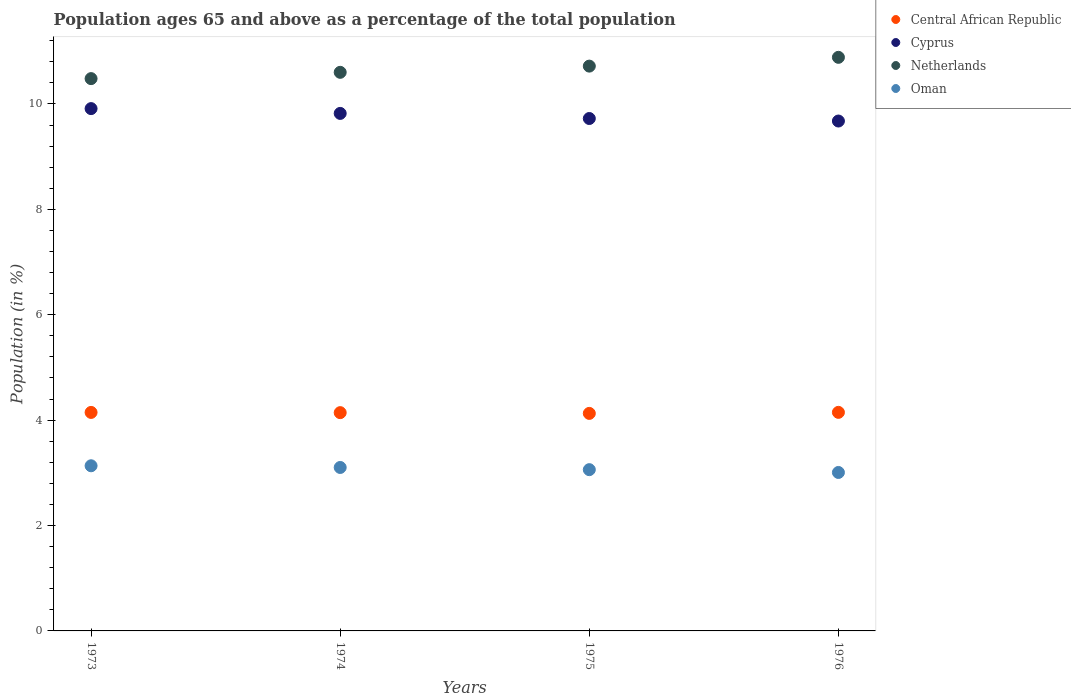Is the number of dotlines equal to the number of legend labels?
Offer a terse response. Yes. What is the percentage of the population ages 65 and above in Central African Republic in 1974?
Make the answer very short. 4.14. Across all years, what is the maximum percentage of the population ages 65 and above in Cyprus?
Give a very brief answer. 9.91. Across all years, what is the minimum percentage of the population ages 65 and above in Oman?
Offer a very short reply. 3.01. In which year was the percentage of the population ages 65 and above in Oman maximum?
Keep it short and to the point. 1973. In which year was the percentage of the population ages 65 and above in Cyprus minimum?
Ensure brevity in your answer.  1976. What is the total percentage of the population ages 65 and above in Netherlands in the graph?
Your answer should be compact. 42.68. What is the difference between the percentage of the population ages 65 and above in Oman in 1974 and that in 1976?
Offer a very short reply. 0.09. What is the difference between the percentage of the population ages 65 and above in Cyprus in 1975 and the percentage of the population ages 65 and above in Central African Republic in 1974?
Make the answer very short. 5.58. What is the average percentage of the population ages 65 and above in Central African Republic per year?
Your response must be concise. 4.14. In the year 1974, what is the difference between the percentage of the population ages 65 and above in Cyprus and percentage of the population ages 65 and above in Oman?
Make the answer very short. 6.72. In how many years, is the percentage of the population ages 65 and above in Netherlands greater than 8?
Ensure brevity in your answer.  4. What is the ratio of the percentage of the population ages 65 and above in Central African Republic in 1973 to that in 1975?
Provide a succinct answer. 1. Is the percentage of the population ages 65 and above in Cyprus in 1973 less than that in 1975?
Give a very brief answer. No. Is the difference between the percentage of the population ages 65 and above in Cyprus in 1973 and 1976 greater than the difference between the percentage of the population ages 65 and above in Oman in 1973 and 1976?
Ensure brevity in your answer.  Yes. What is the difference between the highest and the second highest percentage of the population ages 65 and above in Netherlands?
Provide a short and direct response. 0.17. What is the difference between the highest and the lowest percentage of the population ages 65 and above in Oman?
Provide a short and direct response. 0.13. In how many years, is the percentage of the population ages 65 and above in Netherlands greater than the average percentage of the population ages 65 and above in Netherlands taken over all years?
Your response must be concise. 2. Is it the case that in every year, the sum of the percentage of the population ages 65 and above in Central African Republic and percentage of the population ages 65 and above in Netherlands  is greater than the sum of percentage of the population ages 65 and above in Oman and percentage of the population ages 65 and above in Cyprus?
Provide a succinct answer. Yes. Is it the case that in every year, the sum of the percentage of the population ages 65 and above in Netherlands and percentage of the population ages 65 and above in Cyprus  is greater than the percentage of the population ages 65 and above in Central African Republic?
Ensure brevity in your answer.  Yes. Does the percentage of the population ages 65 and above in Cyprus monotonically increase over the years?
Keep it short and to the point. No. Is the percentage of the population ages 65 and above in Oman strictly greater than the percentage of the population ages 65 and above in Netherlands over the years?
Give a very brief answer. No. How many dotlines are there?
Offer a terse response. 4. Where does the legend appear in the graph?
Give a very brief answer. Top right. How are the legend labels stacked?
Your answer should be very brief. Vertical. What is the title of the graph?
Make the answer very short. Population ages 65 and above as a percentage of the total population. Does "Europe(all income levels)" appear as one of the legend labels in the graph?
Keep it short and to the point. No. What is the label or title of the X-axis?
Make the answer very short. Years. What is the Population (in %) in Central African Republic in 1973?
Offer a very short reply. 4.15. What is the Population (in %) of Cyprus in 1973?
Keep it short and to the point. 9.91. What is the Population (in %) in Netherlands in 1973?
Give a very brief answer. 10.48. What is the Population (in %) in Oman in 1973?
Your answer should be very brief. 3.13. What is the Population (in %) of Central African Republic in 1974?
Offer a terse response. 4.14. What is the Population (in %) of Cyprus in 1974?
Offer a terse response. 9.82. What is the Population (in %) of Netherlands in 1974?
Offer a very short reply. 10.6. What is the Population (in %) in Oman in 1974?
Ensure brevity in your answer.  3.1. What is the Population (in %) in Central African Republic in 1975?
Your response must be concise. 4.13. What is the Population (in %) in Cyprus in 1975?
Keep it short and to the point. 9.72. What is the Population (in %) of Netherlands in 1975?
Give a very brief answer. 10.72. What is the Population (in %) in Oman in 1975?
Offer a terse response. 3.06. What is the Population (in %) in Central African Republic in 1976?
Give a very brief answer. 4.15. What is the Population (in %) of Cyprus in 1976?
Provide a succinct answer. 9.68. What is the Population (in %) of Netherlands in 1976?
Provide a succinct answer. 10.88. What is the Population (in %) in Oman in 1976?
Make the answer very short. 3.01. Across all years, what is the maximum Population (in %) in Central African Republic?
Give a very brief answer. 4.15. Across all years, what is the maximum Population (in %) of Cyprus?
Your response must be concise. 9.91. Across all years, what is the maximum Population (in %) of Netherlands?
Provide a short and direct response. 10.88. Across all years, what is the maximum Population (in %) in Oman?
Keep it short and to the point. 3.13. Across all years, what is the minimum Population (in %) in Central African Republic?
Your response must be concise. 4.13. Across all years, what is the minimum Population (in %) in Cyprus?
Your answer should be very brief. 9.68. Across all years, what is the minimum Population (in %) in Netherlands?
Make the answer very short. 10.48. Across all years, what is the minimum Population (in %) of Oman?
Provide a short and direct response. 3.01. What is the total Population (in %) in Central African Republic in the graph?
Offer a very short reply. 16.56. What is the total Population (in %) in Cyprus in the graph?
Give a very brief answer. 39.13. What is the total Population (in %) of Netherlands in the graph?
Ensure brevity in your answer.  42.68. What is the total Population (in %) in Oman in the graph?
Ensure brevity in your answer.  12.3. What is the difference between the Population (in %) in Central African Republic in 1973 and that in 1974?
Give a very brief answer. 0. What is the difference between the Population (in %) of Cyprus in 1973 and that in 1974?
Offer a very short reply. 0.09. What is the difference between the Population (in %) in Netherlands in 1973 and that in 1974?
Keep it short and to the point. -0.12. What is the difference between the Population (in %) of Oman in 1973 and that in 1974?
Your response must be concise. 0.03. What is the difference between the Population (in %) of Central African Republic in 1973 and that in 1975?
Give a very brief answer. 0.02. What is the difference between the Population (in %) in Cyprus in 1973 and that in 1975?
Provide a short and direct response. 0.19. What is the difference between the Population (in %) of Netherlands in 1973 and that in 1975?
Offer a terse response. -0.24. What is the difference between the Population (in %) of Oman in 1973 and that in 1975?
Offer a very short reply. 0.07. What is the difference between the Population (in %) of Central African Republic in 1973 and that in 1976?
Offer a very short reply. -0. What is the difference between the Population (in %) of Cyprus in 1973 and that in 1976?
Provide a short and direct response. 0.24. What is the difference between the Population (in %) in Netherlands in 1973 and that in 1976?
Give a very brief answer. -0.4. What is the difference between the Population (in %) of Oman in 1973 and that in 1976?
Offer a very short reply. 0.13. What is the difference between the Population (in %) in Central African Republic in 1974 and that in 1975?
Your answer should be compact. 0.01. What is the difference between the Population (in %) in Cyprus in 1974 and that in 1975?
Ensure brevity in your answer.  0.1. What is the difference between the Population (in %) of Netherlands in 1974 and that in 1975?
Give a very brief answer. -0.12. What is the difference between the Population (in %) in Oman in 1974 and that in 1975?
Provide a short and direct response. 0.04. What is the difference between the Population (in %) in Central African Republic in 1974 and that in 1976?
Make the answer very short. -0.01. What is the difference between the Population (in %) of Cyprus in 1974 and that in 1976?
Offer a very short reply. 0.14. What is the difference between the Population (in %) of Netherlands in 1974 and that in 1976?
Your answer should be very brief. -0.28. What is the difference between the Population (in %) in Oman in 1974 and that in 1976?
Your answer should be compact. 0.09. What is the difference between the Population (in %) in Central African Republic in 1975 and that in 1976?
Ensure brevity in your answer.  -0.02. What is the difference between the Population (in %) of Cyprus in 1975 and that in 1976?
Keep it short and to the point. 0.05. What is the difference between the Population (in %) of Netherlands in 1975 and that in 1976?
Make the answer very short. -0.17. What is the difference between the Population (in %) of Oman in 1975 and that in 1976?
Your answer should be compact. 0.05. What is the difference between the Population (in %) in Central African Republic in 1973 and the Population (in %) in Cyprus in 1974?
Make the answer very short. -5.67. What is the difference between the Population (in %) in Central African Republic in 1973 and the Population (in %) in Netherlands in 1974?
Provide a short and direct response. -6.45. What is the difference between the Population (in %) in Central African Republic in 1973 and the Population (in %) in Oman in 1974?
Provide a succinct answer. 1.04. What is the difference between the Population (in %) of Cyprus in 1973 and the Population (in %) of Netherlands in 1974?
Give a very brief answer. -0.69. What is the difference between the Population (in %) in Cyprus in 1973 and the Population (in %) in Oman in 1974?
Keep it short and to the point. 6.81. What is the difference between the Population (in %) in Netherlands in 1973 and the Population (in %) in Oman in 1974?
Your response must be concise. 7.38. What is the difference between the Population (in %) in Central African Republic in 1973 and the Population (in %) in Cyprus in 1975?
Offer a very short reply. -5.58. What is the difference between the Population (in %) of Central African Republic in 1973 and the Population (in %) of Netherlands in 1975?
Provide a short and direct response. -6.57. What is the difference between the Population (in %) of Central African Republic in 1973 and the Population (in %) of Oman in 1975?
Your answer should be compact. 1.09. What is the difference between the Population (in %) of Cyprus in 1973 and the Population (in %) of Netherlands in 1975?
Give a very brief answer. -0.81. What is the difference between the Population (in %) of Cyprus in 1973 and the Population (in %) of Oman in 1975?
Keep it short and to the point. 6.85. What is the difference between the Population (in %) of Netherlands in 1973 and the Population (in %) of Oman in 1975?
Keep it short and to the point. 7.42. What is the difference between the Population (in %) in Central African Republic in 1973 and the Population (in %) in Cyprus in 1976?
Your answer should be compact. -5.53. What is the difference between the Population (in %) in Central African Republic in 1973 and the Population (in %) in Netherlands in 1976?
Keep it short and to the point. -6.74. What is the difference between the Population (in %) of Central African Republic in 1973 and the Population (in %) of Oman in 1976?
Give a very brief answer. 1.14. What is the difference between the Population (in %) of Cyprus in 1973 and the Population (in %) of Netherlands in 1976?
Provide a short and direct response. -0.97. What is the difference between the Population (in %) of Cyprus in 1973 and the Population (in %) of Oman in 1976?
Offer a terse response. 6.9. What is the difference between the Population (in %) of Netherlands in 1973 and the Population (in %) of Oman in 1976?
Your answer should be very brief. 7.47. What is the difference between the Population (in %) in Central African Republic in 1974 and the Population (in %) in Cyprus in 1975?
Provide a short and direct response. -5.58. What is the difference between the Population (in %) of Central African Republic in 1974 and the Population (in %) of Netherlands in 1975?
Keep it short and to the point. -6.58. What is the difference between the Population (in %) of Central African Republic in 1974 and the Population (in %) of Oman in 1975?
Offer a very short reply. 1.08. What is the difference between the Population (in %) in Cyprus in 1974 and the Population (in %) in Netherlands in 1975?
Offer a terse response. -0.9. What is the difference between the Population (in %) in Cyprus in 1974 and the Population (in %) in Oman in 1975?
Make the answer very short. 6.76. What is the difference between the Population (in %) in Netherlands in 1974 and the Population (in %) in Oman in 1975?
Your response must be concise. 7.54. What is the difference between the Population (in %) of Central African Republic in 1974 and the Population (in %) of Cyprus in 1976?
Make the answer very short. -5.53. What is the difference between the Population (in %) in Central African Republic in 1974 and the Population (in %) in Netherlands in 1976?
Provide a short and direct response. -6.74. What is the difference between the Population (in %) in Central African Republic in 1974 and the Population (in %) in Oman in 1976?
Offer a very short reply. 1.14. What is the difference between the Population (in %) of Cyprus in 1974 and the Population (in %) of Netherlands in 1976?
Provide a succinct answer. -1.06. What is the difference between the Population (in %) of Cyprus in 1974 and the Population (in %) of Oman in 1976?
Provide a short and direct response. 6.81. What is the difference between the Population (in %) in Netherlands in 1974 and the Population (in %) in Oman in 1976?
Ensure brevity in your answer.  7.59. What is the difference between the Population (in %) of Central African Republic in 1975 and the Population (in %) of Cyprus in 1976?
Give a very brief answer. -5.55. What is the difference between the Population (in %) in Central African Republic in 1975 and the Population (in %) in Netherlands in 1976?
Offer a very short reply. -6.76. What is the difference between the Population (in %) of Central African Republic in 1975 and the Population (in %) of Oman in 1976?
Your answer should be compact. 1.12. What is the difference between the Population (in %) in Cyprus in 1975 and the Population (in %) in Netherlands in 1976?
Give a very brief answer. -1.16. What is the difference between the Population (in %) in Cyprus in 1975 and the Population (in %) in Oman in 1976?
Offer a terse response. 6.72. What is the difference between the Population (in %) in Netherlands in 1975 and the Population (in %) in Oman in 1976?
Your answer should be very brief. 7.71. What is the average Population (in %) of Central African Republic per year?
Offer a very short reply. 4.14. What is the average Population (in %) of Cyprus per year?
Your answer should be very brief. 9.78. What is the average Population (in %) of Netherlands per year?
Provide a short and direct response. 10.67. What is the average Population (in %) in Oman per year?
Your answer should be compact. 3.08. In the year 1973, what is the difference between the Population (in %) of Central African Republic and Population (in %) of Cyprus?
Ensure brevity in your answer.  -5.77. In the year 1973, what is the difference between the Population (in %) in Central African Republic and Population (in %) in Netherlands?
Give a very brief answer. -6.33. In the year 1973, what is the difference between the Population (in %) in Central African Republic and Population (in %) in Oman?
Provide a succinct answer. 1.01. In the year 1973, what is the difference between the Population (in %) of Cyprus and Population (in %) of Netherlands?
Keep it short and to the point. -0.57. In the year 1973, what is the difference between the Population (in %) in Cyprus and Population (in %) in Oman?
Your response must be concise. 6.78. In the year 1973, what is the difference between the Population (in %) in Netherlands and Population (in %) in Oman?
Ensure brevity in your answer.  7.35. In the year 1974, what is the difference between the Population (in %) of Central African Republic and Population (in %) of Cyprus?
Your response must be concise. -5.68. In the year 1974, what is the difference between the Population (in %) in Central African Republic and Population (in %) in Netherlands?
Provide a short and direct response. -6.46. In the year 1974, what is the difference between the Population (in %) in Central African Republic and Population (in %) in Oman?
Make the answer very short. 1.04. In the year 1974, what is the difference between the Population (in %) in Cyprus and Population (in %) in Netherlands?
Provide a short and direct response. -0.78. In the year 1974, what is the difference between the Population (in %) in Cyprus and Population (in %) in Oman?
Offer a terse response. 6.72. In the year 1974, what is the difference between the Population (in %) of Netherlands and Population (in %) of Oman?
Give a very brief answer. 7.5. In the year 1975, what is the difference between the Population (in %) in Central African Republic and Population (in %) in Cyprus?
Offer a terse response. -5.6. In the year 1975, what is the difference between the Population (in %) in Central African Republic and Population (in %) in Netherlands?
Ensure brevity in your answer.  -6.59. In the year 1975, what is the difference between the Population (in %) of Central African Republic and Population (in %) of Oman?
Keep it short and to the point. 1.07. In the year 1975, what is the difference between the Population (in %) in Cyprus and Population (in %) in Netherlands?
Keep it short and to the point. -0.99. In the year 1975, what is the difference between the Population (in %) of Cyprus and Population (in %) of Oman?
Ensure brevity in your answer.  6.66. In the year 1975, what is the difference between the Population (in %) of Netherlands and Population (in %) of Oman?
Your answer should be compact. 7.66. In the year 1976, what is the difference between the Population (in %) of Central African Republic and Population (in %) of Cyprus?
Provide a short and direct response. -5.53. In the year 1976, what is the difference between the Population (in %) in Central African Republic and Population (in %) in Netherlands?
Your response must be concise. -6.74. In the year 1976, what is the difference between the Population (in %) in Central African Republic and Population (in %) in Oman?
Your answer should be compact. 1.14. In the year 1976, what is the difference between the Population (in %) of Cyprus and Population (in %) of Netherlands?
Your answer should be very brief. -1.21. In the year 1976, what is the difference between the Population (in %) in Cyprus and Population (in %) in Oman?
Your answer should be very brief. 6.67. In the year 1976, what is the difference between the Population (in %) in Netherlands and Population (in %) in Oman?
Make the answer very short. 7.88. What is the ratio of the Population (in %) in Central African Republic in 1973 to that in 1974?
Offer a terse response. 1. What is the ratio of the Population (in %) in Cyprus in 1973 to that in 1974?
Your response must be concise. 1.01. What is the ratio of the Population (in %) of Netherlands in 1973 to that in 1974?
Keep it short and to the point. 0.99. What is the ratio of the Population (in %) in Oman in 1973 to that in 1974?
Your answer should be very brief. 1.01. What is the ratio of the Population (in %) in Central African Republic in 1973 to that in 1975?
Make the answer very short. 1. What is the ratio of the Population (in %) in Cyprus in 1973 to that in 1975?
Give a very brief answer. 1.02. What is the ratio of the Population (in %) of Netherlands in 1973 to that in 1975?
Offer a terse response. 0.98. What is the ratio of the Population (in %) of Oman in 1973 to that in 1975?
Your answer should be very brief. 1.02. What is the ratio of the Population (in %) of Central African Republic in 1973 to that in 1976?
Keep it short and to the point. 1. What is the ratio of the Population (in %) of Cyprus in 1973 to that in 1976?
Offer a very short reply. 1.02. What is the ratio of the Population (in %) in Netherlands in 1973 to that in 1976?
Provide a succinct answer. 0.96. What is the ratio of the Population (in %) of Oman in 1973 to that in 1976?
Your response must be concise. 1.04. What is the ratio of the Population (in %) of Oman in 1974 to that in 1975?
Your answer should be very brief. 1.01. What is the ratio of the Population (in %) of Cyprus in 1974 to that in 1976?
Keep it short and to the point. 1.01. What is the ratio of the Population (in %) of Netherlands in 1974 to that in 1976?
Provide a succinct answer. 0.97. What is the ratio of the Population (in %) of Oman in 1974 to that in 1976?
Keep it short and to the point. 1.03. What is the ratio of the Population (in %) in Central African Republic in 1975 to that in 1976?
Your answer should be compact. 1. What is the ratio of the Population (in %) of Netherlands in 1975 to that in 1976?
Your answer should be very brief. 0.98. What is the ratio of the Population (in %) of Oman in 1975 to that in 1976?
Keep it short and to the point. 1.02. What is the difference between the highest and the second highest Population (in %) of Central African Republic?
Your answer should be very brief. 0. What is the difference between the highest and the second highest Population (in %) of Cyprus?
Keep it short and to the point. 0.09. What is the difference between the highest and the second highest Population (in %) of Netherlands?
Make the answer very short. 0.17. What is the difference between the highest and the second highest Population (in %) of Oman?
Give a very brief answer. 0.03. What is the difference between the highest and the lowest Population (in %) in Central African Republic?
Ensure brevity in your answer.  0.02. What is the difference between the highest and the lowest Population (in %) of Cyprus?
Your answer should be compact. 0.24. What is the difference between the highest and the lowest Population (in %) of Netherlands?
Provide a succinct answer. 0.4. What is the difference between the highest and the lowest Population (in %) in Oman?
Your response must be concise. 0.13. 